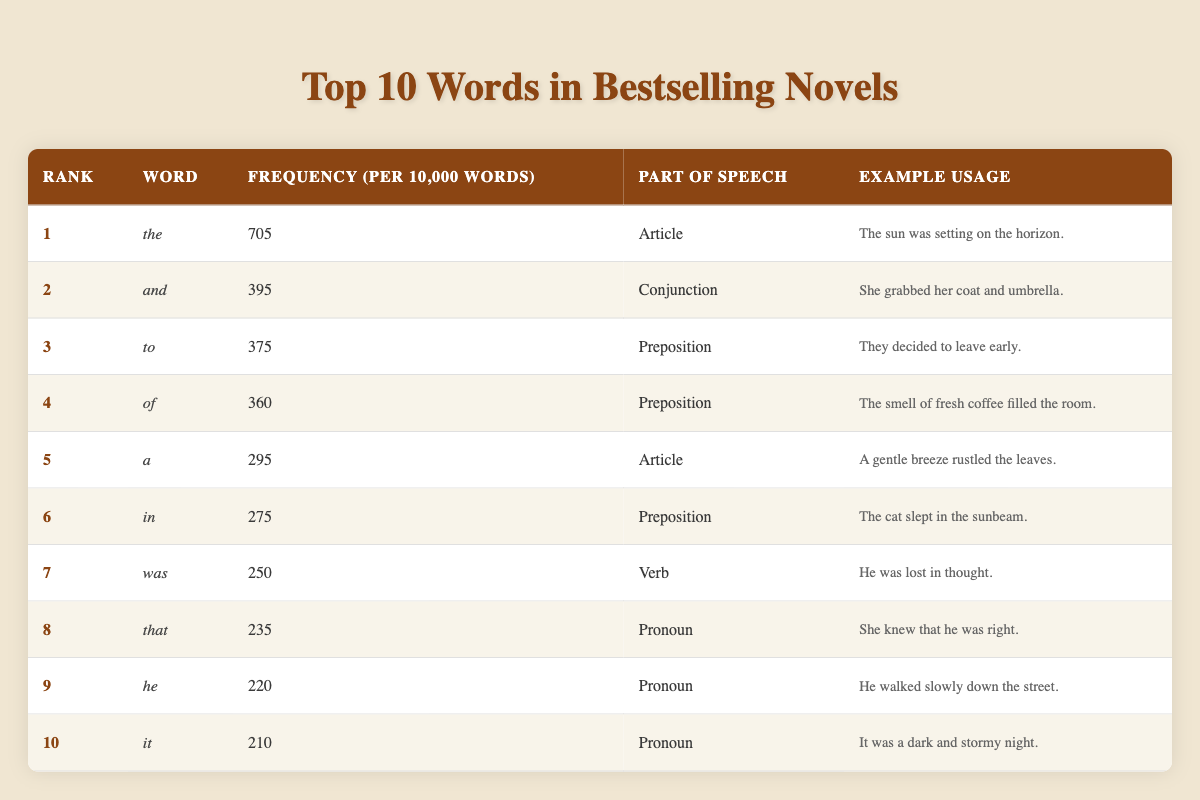What is the most frequently used word in bestselling novels? According to the table, "the" is the most frequently used word with a frequency of 705 per 10,000 words.
Answer: the How many times does the word "and" appear per 10,000 words? From the table, "and" has a frequency of 395 per 10,000 words.
Answer: 395 Which part of speech does the word "was" belong to? The table indicates that "was" is categorized as a verb.
Answer: Verb Is "it" used more frequently than "he"? By comparing the frequencies, "it" appears 210 times while "he" appears 220 times, indicating that "he" is used more. Therefore, the statement is true.
Answer: No What is the total frequency of the top three words? To find the total frequency, add the three highest frequencies: 705 (the) + 395 (and) + 375 (to) = 1475.
Answer: 1475 Which word has the lowest frequency and what is it? Scanning the table, the word with the lowest frequency is "it," which has a frequency of 210 per 10,000 words.
Answer: it Are there more articles or prepositions in the top 10 list? There are 3 articles ("the," "a") and 4 prepositions ("to," "of," "in"), suggesting that prepositions are more frequent in the list. Therefore, the answer is yes.
Answer: Yes What is the average frequency of all ten words listed? To find the average, sum all frequencies: 705 + 395 + 375 + 360 + 295 + 275 + 250 + 235 + 220 + 210 = 3090, then divide by 10, resulting in an average of 309.
Answer: 309 Which word is used most as a pronoun? The table shows that "he" has a frequency of 220, making it the most frequently used pronoun among the listed words.
Answer: he 